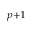<formula> <loc_0><loc_0><loc_500><loc_500>_ { p + 1 }</formula> 